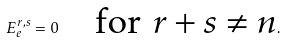<formula> <loc_0><loc_0><loc_500><loc_500>E _ { e } ^ { r , s } = 0 \quad \text {for $r+s\neq n$} .</formula> 